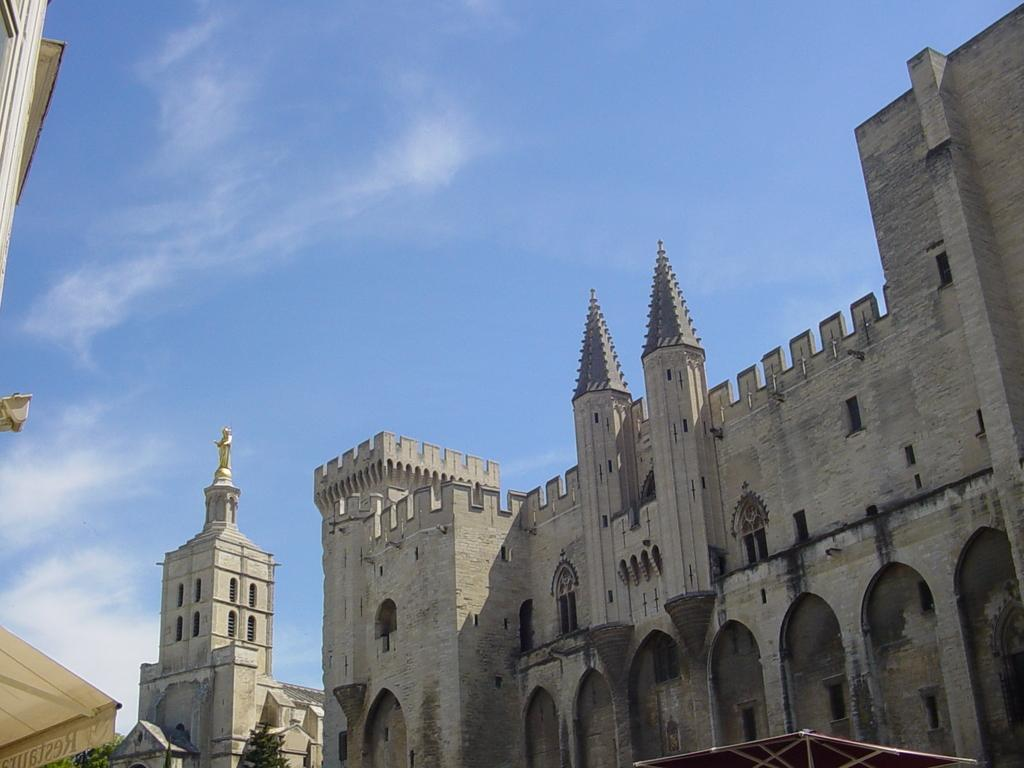What type of structures can be seen in the image? There are buildings in the image. What other natural elements are present in the image? There are trees in the image. Is there any artwork or sculpture visible in the image? Yes, there is a statue in the image. What can be seen in the background of the image? The sky is visible in the image, and clouds are present in the sky. What type of grape is being used to make the stew in the image? There is no grape or stew present in the image; it features buildings, trees, a statue, and a sky with clouds. 